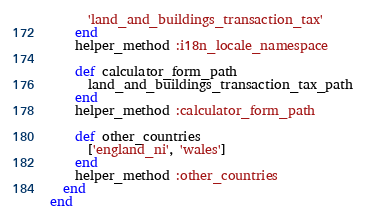<code> <loc_0><loc_0><loc_500><loc_500><_Ruby_>      'land_and_buildings_transaction_tax'
    end
    helper_method :i18n_locale_namespace

    def calculator_form_path
      land_and_buildings_transaction_tax_path
    end
    helper_method :calculator_form_path

    def other_countries
      ['england_ni', 'wales']
    end
    helper_method :other_countries
  end
end
</code> 